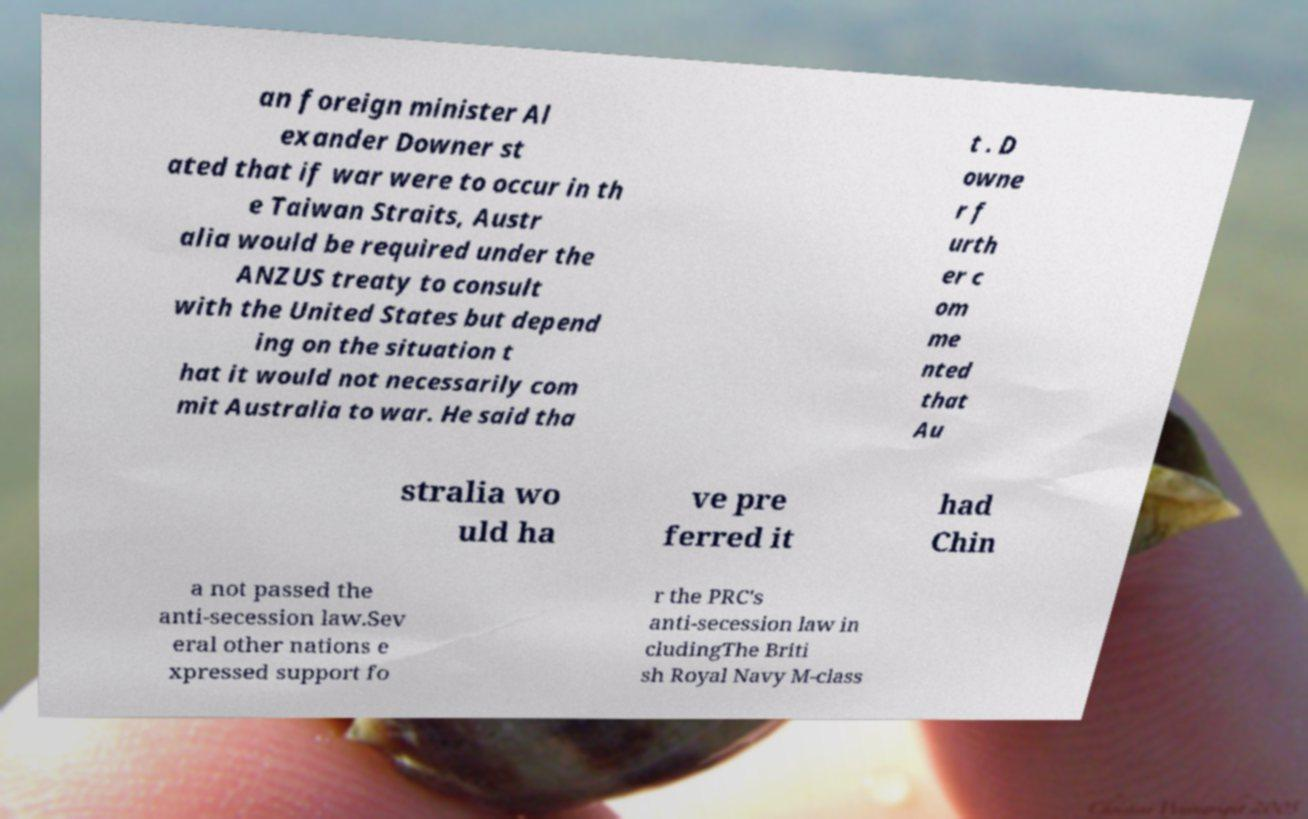Please read and relay the text visible in this image. What does it say? an foreign minister Al exander Downer st ated that if war were to occur in th e Taiwan Straits, Austr alia would be required under the ANZUS treaty to consult with the United States but depend ing on the situation t hat it would not necessarily com mit Australia to war. He said tha t . D owne r f urth er c om me nted that Au stralia wo uld ha ve pre ferred it had Chin a not passed the anti-secession law.Sev eral other nations e xpressed support fo r the PRC's anti-secession law in cludingThe Briti sh Royal Navy M-class 